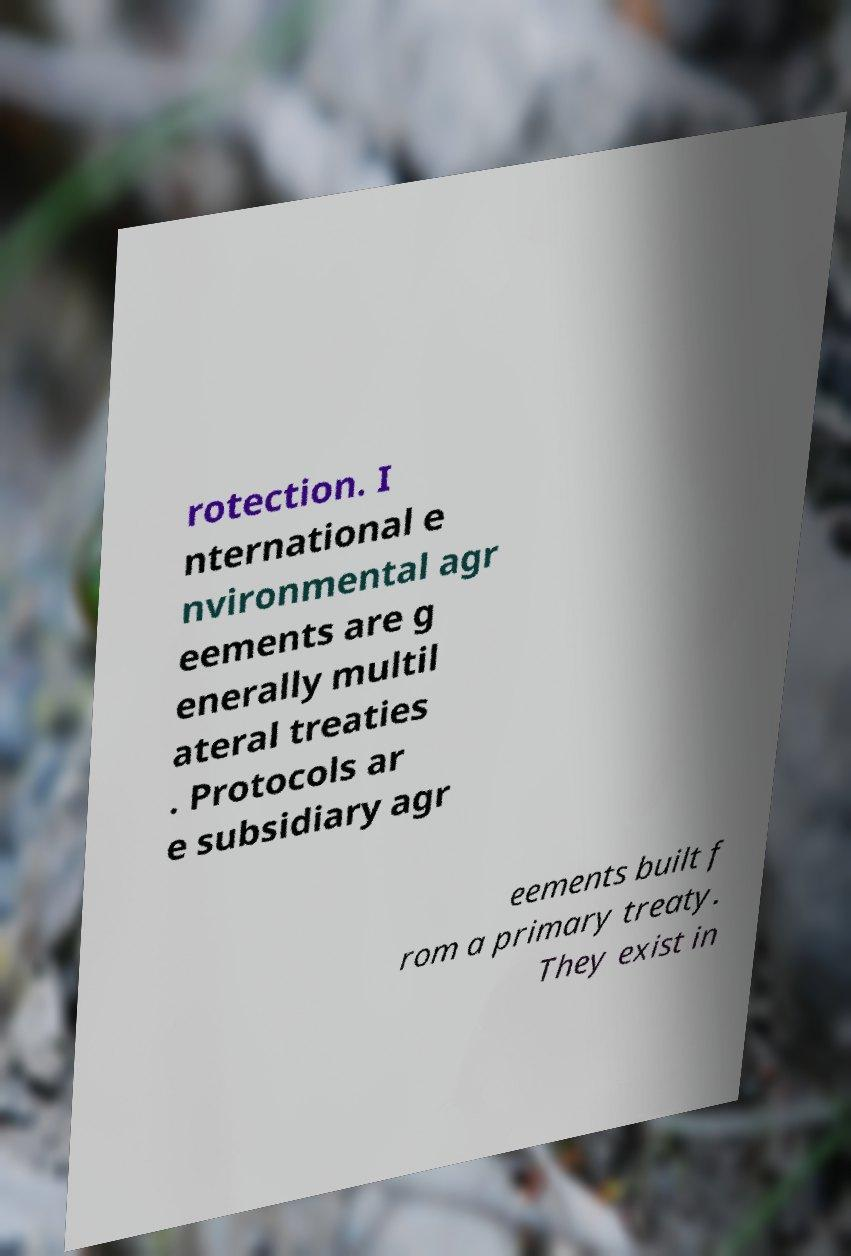There's text embedded in this image that I need extracted. Can you transcribe it verbatim? rotection. I nternational e nvironmental agr eements are g enerally multil ateral treaties . Protocols ar e subsidiary agr eements built f rom a primary treaty. They exist in 